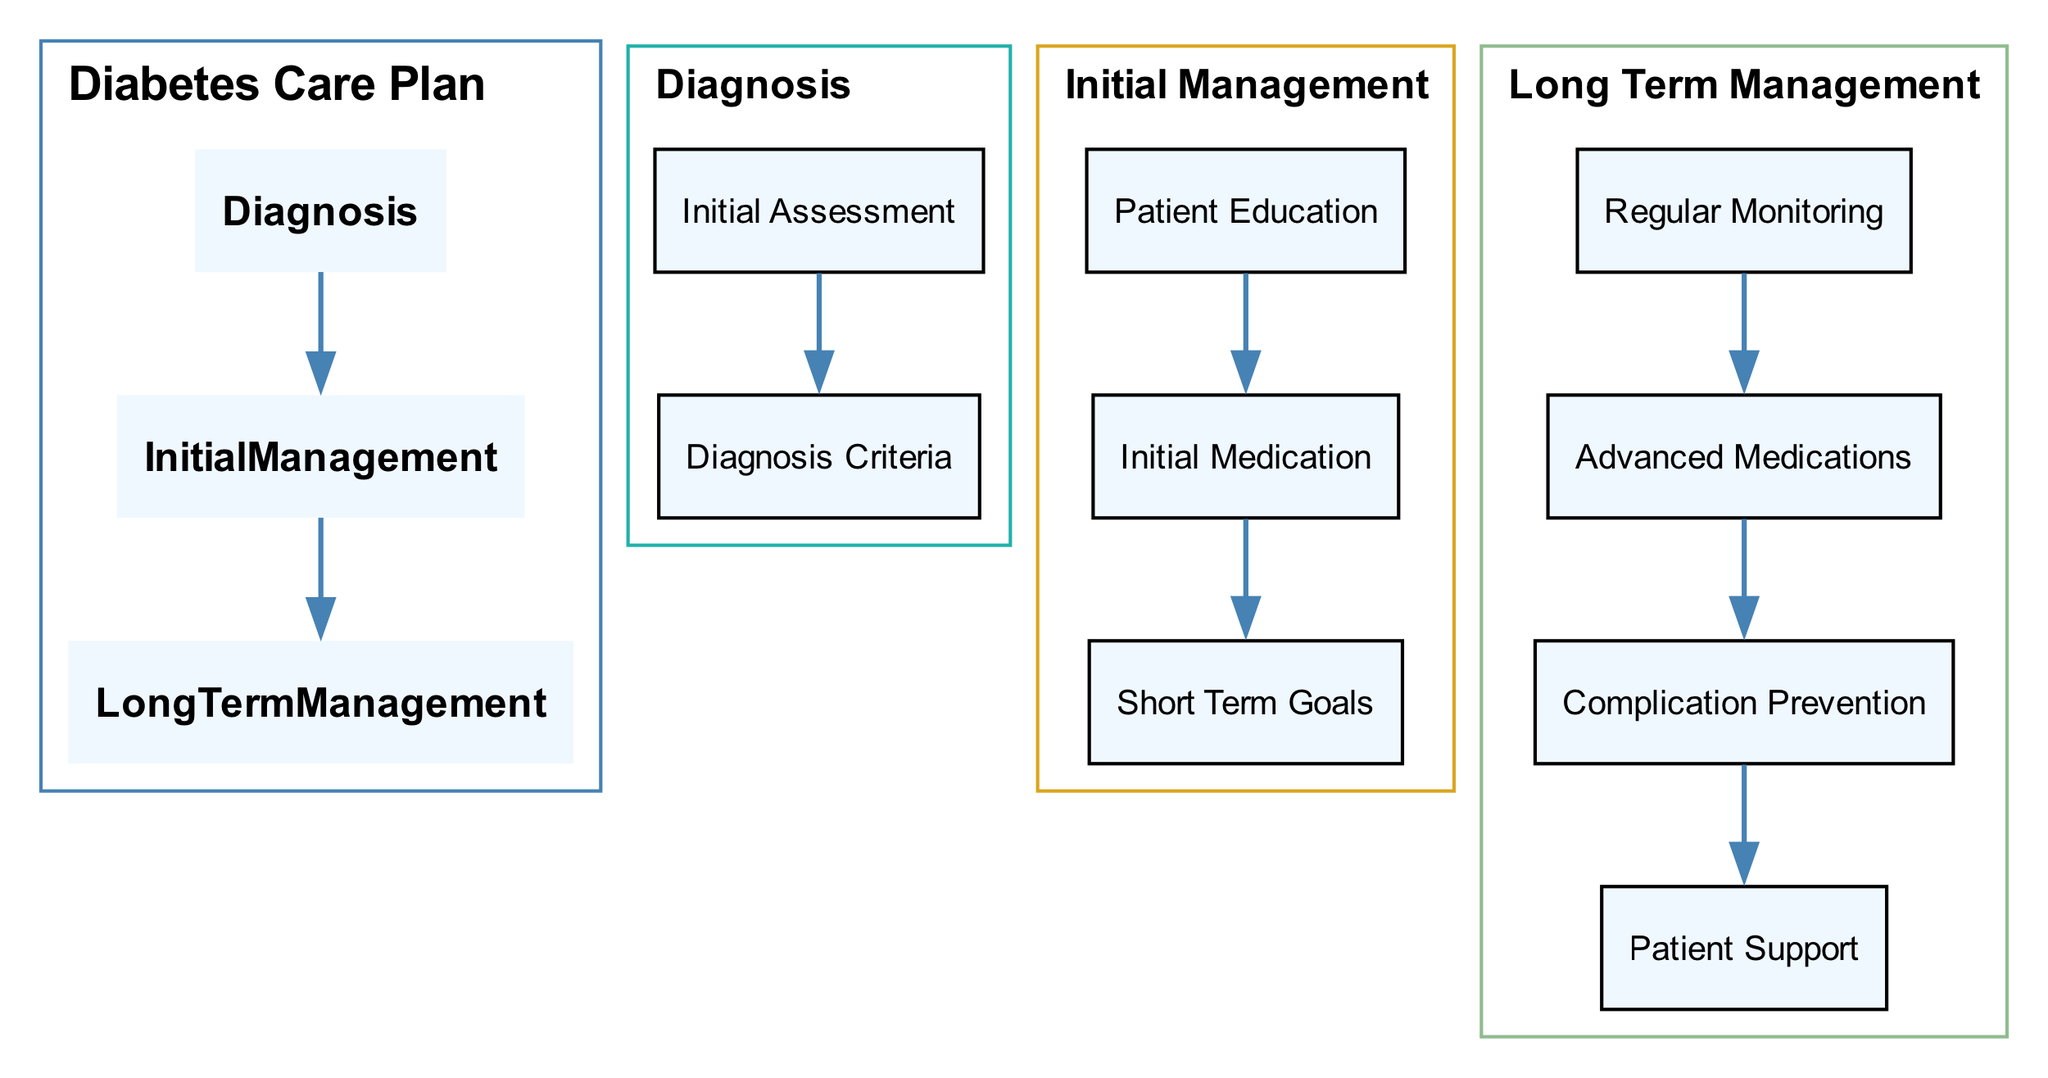What is the first step in the Diabetes Care Plan? The first step in the Diabetes Care Plan is "Diagnosis". It is the initial stage from which further management actions will flow.
Answer: Diagnosis How many main stages are in the Diabetes Care Plan? The diagram shows three main stages: Diagnosis, Initial Management, and Long Term Management. Counting these stages, we see there are three.
Answer: 3 What are the two main components of the Initial Management stage? In the Initial Management stage, the two main components are "Patient Education" and "Initial Medication". These represent foundational elements in managing diabetes initially.
Answer: Patient Education and Initial Medication What is the target FPG level for diabetes diagnosis? The target FPG level for diabetes diagnosis is ">= 126 mg/dL". This threshold helps in identifying diabetes within the initial diagnosis.
Answer: >= 126 mg/dL Which component follows "Regular Monitoring" in Long Term Management? The component that follows "Regular Monitoring" in Long Term Management is "Advanced Medications". This indicates progression from monitoring to potential medication adjustments.
Answer: Advanced Medications What type of support is included under Patient Support? Under Patient Support, "Support Groups" are included as a primary resource for individuals managing diabetes. This emphasizes community engagement in diabetes care.
Answer: Support Groups What are the specific criteria for diagnosing diabetes related to HbA1c? The specific criterion for diagnosing diabetes related to HbA1c is ">= 6.5%". This value is essential for determining diabetic conditions through laboratory tests.
Answer: >= 6.5% What is the recommended frequency for regular HbA1c checks? The recommended frequency for regular HbA1c checks is "every 3 months". This is critical for monitoring long-term blood sugar control in patients with diabetes.
Answer: every 3 months What type of insulin therapy is mentioned in the Advanced Medications section? "Insulin Therapy" is the type of insulin therapy mentioned. It encompasses different forms to manage diabetes effectively in patients requiring more than oral medications.
Answer: Insulin Therapy 